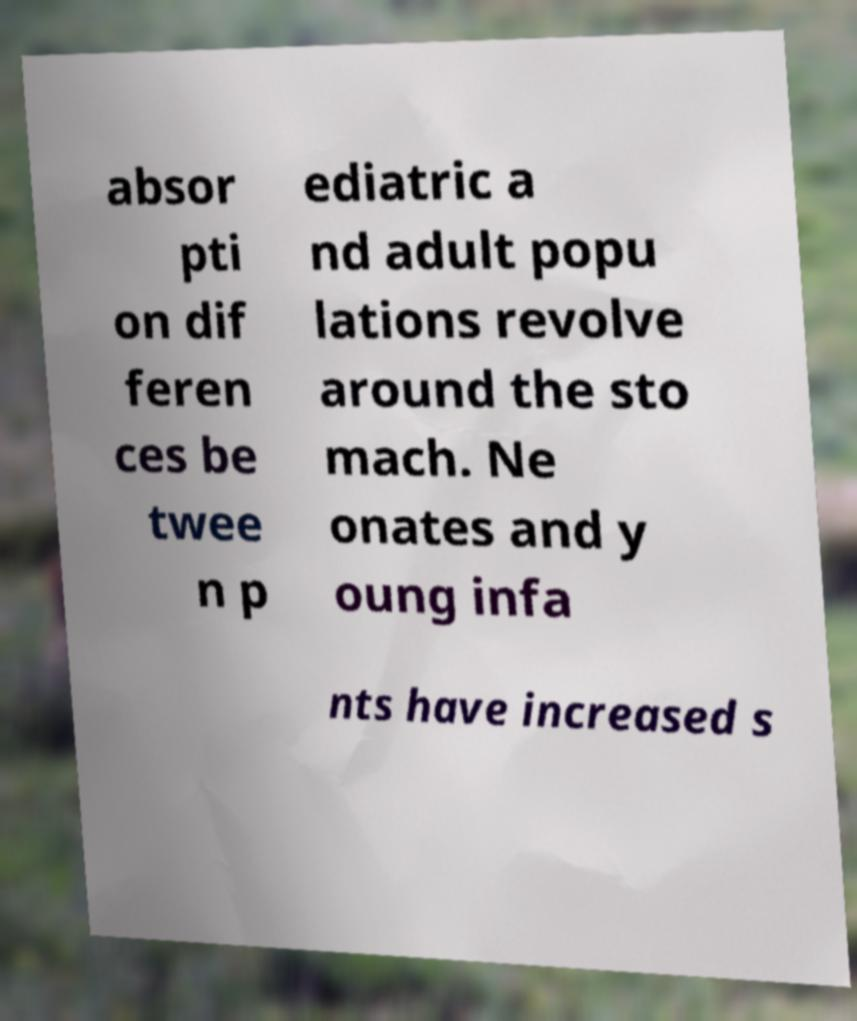Please read and relay the text visible in this image. What does it say? absor pti on dif feren ces be twee n p ediatric a nd adult popu lations revolve around the sto mach. Ne onates and y oung infa nts have increased s 